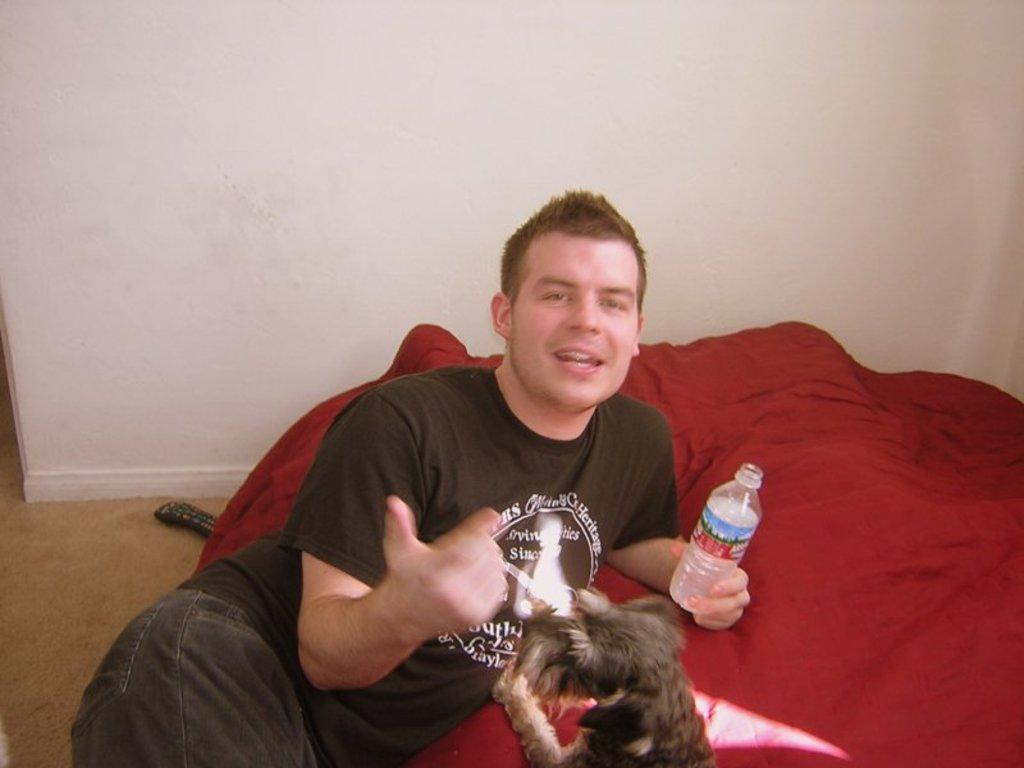What is the man in the image doing? The man is lying down in the image. What object is the man holding? The man is holding a bottle. What type of animal is present in the image? There is a dog in the image. What can be seen in the background of the image? There is a wall in the image. What object is located in the back of the image? There is a remote in the back of the image. What type of magic is the man performing in the image? There is no magic or any magical activity present in the image. What time is indicated by the clock in the image? There is no clock present in the image. 